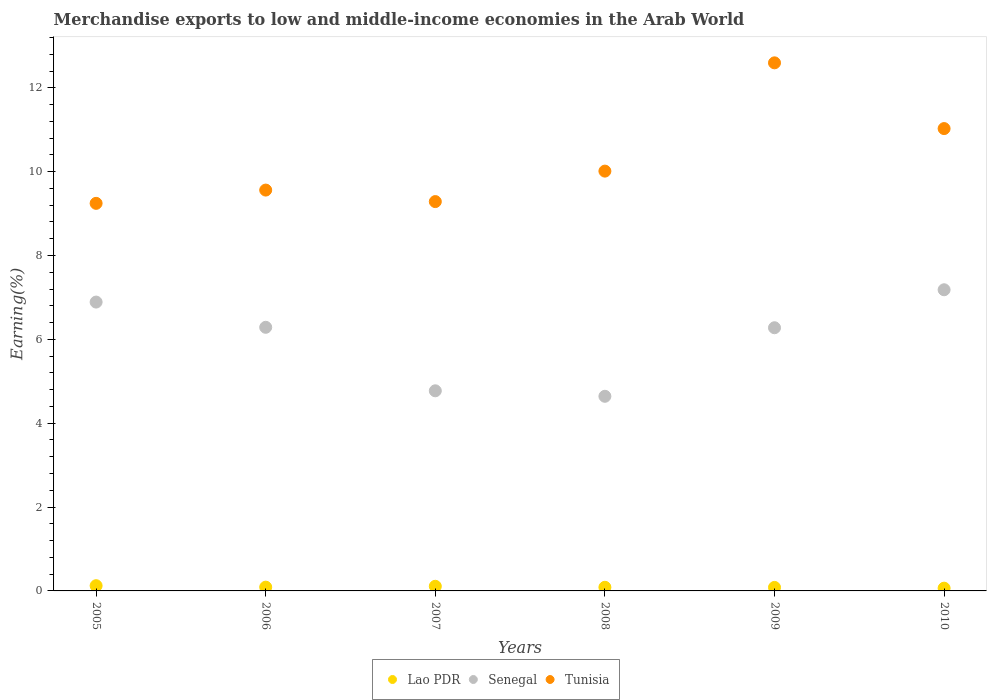Is the number of dotlines equal to the number of legend labels?
Your response must be concise. Yes. What is the percentage of amount earned from merchandise exports in Tunisia in 2005?
Provide a succinct answer. 9.24. Across all years, what is the maximum percentage of amount earned from merchandise exports in Senegal?
Offer a very short reply. 7.18. Across all years, what is the minimum percentage of amount earned from merchandise exports in Tunisia?
Your response must be concise. 9.24. In which year was the percentage of amount earned from merchandise exports in Tunisia maximum?
Ensure brevity in your answer.  2009. What is the total percentage of amount earned from merchandise exports in Tunisia in the graph?
Your answer should be compact. 61.73. What is the difference between the percentage of amount earned from merchandise exports in Senegal in 2005 and that in 2006?
Give a very brief answer. 0.6. What is the difference between the percentage of amount earned from merchandise exports in Tunisia in 2006 and the percentage of amount earned from merchandise exports in Senegal in 2008?
Give a very brief answer. 4.92. What is the average percentage of amount earned from merchandise exports in Senegal per year?
Offer a terse response. 6.01. In the year 2007, what is the difference between the percentage of amount earned from merchandise exports in Lao PDR and percentage of amount earned from merchandise exports in Senegal?
Give a very brief answer. -4.66. In how many years, is the percentage of amount earned from merchandise exports in Lao PDR greater than 8 %?
Make the answer very short. 0. What is the ratio of the percentage of amount earned from merchandise exports in Senegal in 2005 to that in 2008?
Provide a short and direct response. 1.48. Is the difference between the percentage of amount earned from merchandise exports in Lao PDR in 2005 and 2010 greater than the difference between the percentage of amount earned from merchandise exports in Senegal in 2005 and 2010?
Offer a terse response. Yes. What is the difference between the highest and the second highest percentage of amount earned from merchandise exports in Lao PDR?
Your answer should be compact. 0.01. What is the difference between the highest and the lowest percentage of amount earned from merchandise exports in Lao PDR?
Your answer should be compact. 0.06. In how many years, is the percentage of amount earned from merchandise exports in Tunisia greater than the average percentage of amount earned from merchandise exports in Tunisia taken over all years?
Keep it short and to the point. 2. Is the sum of the percentage of amount earned from merchandise exports in Tunisia in 2005 and 2010 greater than the maximum percentage of amount earned from merchandise exports in Senegal across all years?
Offer a very short reply. Yes. Is it the case that in every year, the sum of the percentage of amount earned from merchandise exports in Senegal and percentage of amount earned from merchandise exports in Tunisia  is greater than the percentage of amount earned from merchandise exports in Lao PDR?
Offer a very short reply. Yes. Is the percentage of amount earned from merchandise exports in Lao PDR strictly less than the percentage of amount earned from merchandise exports in Senegal over the years?
Make the answer very short. Yes. How many dotlines are there?
Your answer should be compact. 3. What is the difference between two consecutive major ticks on the Y-axis?
Ensure brevity in your answer.  2. Does the graph contain any zero values?
Make the answer very short. No. Does the graph contain grids?
Your answer should be compact. No. How many legend labels are there?
Keep it short and to the point. 3. What is the title of the graph?
Offer a very short reply. Merchandise exports to low and middle-income economies in the Arab World. What is the label or title of the X-axis?
Give a very brief answer. Years. What is the label or title of the Y-axis?
Keep it short and to the point. Earning(%). What is the Earning(%) in Lao PDR in 2005?
Provide a succinct answer. 0.12. What is the Earning(%) in Senegal in 2005?
Keep it short and to the point. 6.89. What is the Earning(%) of Tunisia in 2005?
Provide a short and direct response. 9.24. What is the Earning(%) of Lao PDR in 2006?
Your answer should be very brief. 0.09. What is the Earning(%) of Senegal in 2006?
Offer a very short reply. 6.29. What is the Earning(%) in Tunisia in 2006?
Your answer should be compact. 9.56. What is the Earning(%) of Lao PDR in 2007?
Your answer should be compact. 0.11. What is the Earning(%) in Senegal in 2007?
Make the answer very short. 4.77. What is the Earning(%) in Tunisia in 2007?
Offer a very short reply. 9.29. What is the Earning(%) in Lao PDR in 2008?
Provide a short and direct response. 0.09. What is the Earning(%) in Senegal in 2008?
Give a very brief answer. 4.64. What is the Earning(%) of Tunisia in 2008?
Provide a short and direct response. 10.01. What is the Earning(%) in Lao PDR in 2009?
Make the answer very short. 0.08. What is the Earning(%) of Senegal in 2009?
Keep it short and to the point. 6.28. What is the Earning(%) in Tunisia in 2009?
Offer a terse response. 12.6. What is the Earning(%) of Lao PDR in 2010?
Make the answer very short. 0.07. What is the Earning(%) of Senegal in 2010?
Offer a very short reply. 7.18. What is the Earning(%) of Tunisia in 2010?
Make the answer very short. 11.03. Across all years, what is the maximum Earning(%) of Lao PDR?
Give a very brief answer. 0.12. Across all years, what is the maximum Earning(%) of Senegal?
Make the answer very short. 7.18. Across all years, what is the maximum Earning(%) of Tunisia?
Keep it short and to the point. 12.6. Across all years, what is the minimum Earning(%) of Lao PDR?
Your answer should be compact. 0.07. Across all years, what is the minimum Earning(%) in Senegal?
Your response must be concise. 4.64. Across all years, what is the minimum Earning(%) of Tunisia?
Provide a succinct answer. 9.24. What is the total Earning(%) of Lao PDR in the graph?
Offer a very short reply. 0.56. What is the total Earning(%) of Senegal in the graph?
Your answer should be compact. 36.05. What is the total Earning(%) in Tunisia in the graph?
Provide a succinct answer. 61.73. What is the difference between the Earning(%) of Lao PDR in 2005 and that in 2006?
Provide a succinct answer. 0.03. What is the difference between the Earning(%) of Senegal in 2005 and that in 2006?
Give a very brief answer. 0.6. What is the difference between the Earning(%) of Tunisia in 2005 and that in 2006?
Keep it short and to the point. -0.32. What is the difference between the Earning(%) of Lao PDR in 2005 and that in 2007?
Give a very brief answer. 0.01. What is the difference between the Earning(%) in Senegal in 2005 and that in 2007?
Your answer should be compact. 2.12. What is the difference between the Earning(%) in Tunisia in 2005 and that in 2007?
Give a very brief answer. -0.04. What is the difference between the Earning(%) in Lao PDR in 2005 and that in 2008?
Give a very brief answer. 0.04. What is the difference between the Earning(%) of Senegal in 2005 and that in 2008?
Your response must be concise. 2.25. What is the difference between the Earning(%) in Tunisia in 2005 and that in 2008?
Your response must be concise. -0.77. What is the difference between the Earning(%) of Lao PDR in 2005 and that in 2009?
Ensure brevity in your answer.  0.04. What is the difference between the Earning(%) of Senegal in 2005 and that in 2009?
Offer a very short reply. 0.61. What is the difference between the Earning(%) of Tunisia in 2005 and that in 2009?
Offer a very short reply. -3.35. What is the difference between the Earning(%) in Lao PDR in 2005 and that in 2010?
Your response must be concise. 0.06. What is the difference between the Earning(%) in Senegal in 2005 and that in 2010?
Provide a succinct answer. -0.29. What is the difference between the Earning(%) of Tunisia in 2005 and that in 2010?
Offer a very short reply. -1.78. What is the difference between the Earning(%) in Lao PDR in 2006 and that in 2007?
Your response must be concise. -0.02. What is the difference between the Earning(%) of Senegal in 2006 and that in 2007?
Make the answer very short. 1.51. What is the difference between the Earning(%) of Tunisia in 2006 and that in 2007?
Provide a succinct answer. 0.27. What is the difference between the Earning(%) of Lao PDR in 2006 and that in 2008?
Provide a short and direct response. 0. What is the difference between the Earning(%) of Senegal in 2006 and that in 2008?
Offer a very short reply. 1.65. What is the difference between the Earning(%) in Tunisia in 2006 and that in 2008?
Your response must be concise. -0.45. What is the difference between the Earning(%) of Lao PDR in 2006 and that in 2009?
Your response must be concise. 0.01. What is the difference between the Earning(%) in Senegal in 2006 and that in 2009?
Ensure brevity in your answer.  0.01. What is the difference between the Earning(%) of Tunisia in 2006 and that in 2009?
Provide a short and direct response. -3.03. What is the difference between the Earning(%) in Lao PDR in 2006 and that in 2010?
Offer a terse response. 0.02. What is the difference between the Earning(%) in Senegal in 2006 and that in 2010?
Offer a very short reply. -0.9. What is the difference between the Earning(%) of Tunisia in 2006 and that in 2010?
Provide a short and direct response. -1.47. What is the difference between the Earning(%) in Lao PDR in 2007 and that in 2008?
Offer a terse response. 0.02. What is the difference between the Earning(%) of Senegal in 2007 and that in 2008?
Keep it short and to the point. 0.13. What is the difference between the Earning(%) of Tunisia in 2007 and that in 2008?
Offer a very short reply. -0.73. What is the difference between the Earning(%) of Lao PDR in 2007 and that in 2009?
Offer a terse response. 0.03. What is the difference between the Earning(%) of Senegal in 2007 and that in 2009?
Make the answer very short. -1.5. What is the difference between the Earning(%) of Tunisia in 2007 and that in 2009?
Offer a terse response. -3.31. What is the difference between the Earning(%) in Lao PDR in 2007 and that in 2010?
Your response must be concise. 0.04. What is the difference between the Earning(%) of Senegal in 2007 and that in 2010?
Your answer should be compact. -2.41. What is the difference between the Earning(%) in Tunisia in 2007 and that in 2010?
Your answer should be compact. -1.74. What is the difference between the Earning(%) of Lao PDR in 2008 and that in 2009?
Your response must be concise. 0. What is the difference between the Earning(%) of Senegal in 2008 and that in 2009?
Provide a succinct answer. -1.64. What is the difference between the Earning(%) in Tunisia in 2008 and that in 2009?
Keep it short and to the point. -2.58. What is the difference between the Earning(%) in Lao PDR in 2008 and that in 2010?
Provide a short and direct response. 0.02. What is the difference between the Earning(%) of Senegal in 2008 and that in 2010?
Ensure brevity in your answer.  -2.54. What is the difference between the Earning(%) of Tunisia in 2008 and that in 2010?
Provide a succinct answer. -1.01. What is the difference between the Earning(%) in Lao PDR in 2009 and that in 2010?
Give a very brief answer. 0.02. What is the difference between the Earning(%) of Senegal in 2009 and that in 2010?
Your answer should be very brief. -0.91. What is the difference between the Earning(%) in Tunisia in 2009 and that in 2010?
Offer a very short reply. 1.57. What is the difference between the Earning(%) in Lao PDR in 2005 and the Earning(%) in Senegal in 2006?
Offer a very short reply. -6.16. What is the difference between the Earning(%) of Lao PDR in 2005 and the Earning(%) of Tunisia in 2006?
Make the answer very short. -9.44. What is the difference between the Earning(%) of Senegal in 2005 and the Earning(%) of Tunisia in 2006?
Offer a very short reply. -2.67. What is the difference between the Earning(%) of Lao PDR in 2005 and the Earning(%) of Senegal in 2007?
Provide a short and direct response. -4.65. What is the difference between the Earning(%) of Lao PDR in 2005 and the Earning(%) of Tunisia in 2007?
Your answer should be compact. -9.16. What is the difference between the Earning(%) of Senegal in 2005 and the Earning(%) of Tunisia in 2007?
Keep it short and to the point. -2.4. What is the difference between the Earning(%) of Lao PDR in 2005 and the Earning(%) of Senegal in 2008?
Give a very brief answer. -4.52. What is the difference between the Earning(%) of Lao PDR in 2005 and the Earning(%) of Tunisia in 2008?
Give a very brief answer. -9.89. What is the difference between the Earning(%) of Senegal in 2005 and the Earning(%) of Tunisia in 2008?
Offer a very short reply. -3.12. What is the difference between the Earning(%) in Lao PDR in 2005 and the Earning(%) in Senegal in 2009?
Make the answer very short. -6.15. What is the difference between the Earning(%) in Lao PDR in 2005 and the Earning(%) in Tunisia in 2009?
Provide a short and direct response. -12.47. What is the difference between the Earning(%) in Senegal in 2005 and the Earning(%) in Tunisia in 2009?
Make the answer very short. -5.71. What is the difference between the Earning(%) in Lao PDR in 2005 and the Earning(%) in Senegal in 2010?
Keep it short and to the point. -7.06. What is the difference between the Earning(%) in Lao PDR in 2005 and the Earning(%) in Tunisia in 2010?
Your response must be concise. -10.9. What is the difference between the Earning(%) in Senegal in 2005 and the Earning(%) in Tunisia in 2010?
Provide a succinct answer. -4.14. What is the difference between the Earning(%) in Lao PDR in 2006 and the Earning(%) in Senegal in 2007?
Make the answer very short. -4.68. What is the difference between the Earning(%) of Lao PDR in 2006 and the Earning(%) of Tunisia in 2007?
Provide a succinct answer. -9.2. What is the difference between the Earning(%) in Senegal in 2006 and the Earning(%) in Tunisia in 2007?
Offer a very short reply. -3. What is the difference between the Earning(%) of Lao PDR in 2006 and the Earning(%) of Senegal in 2008?
Give a very brief answer. -4.55. What is the difference between the Earning(%) in Lao PDR in 2006 and the Earning(%) in Tunisia in 2008?
Your answer should be compact. -9.92. What is the difference between the Earning(%) of Senegal in 2006 and the Earning(%) of Tunisia in 2008?
Make the answer very short. -3.73. What is the difference between the Earning(%) in Lao PDR in 2006 and the Earning(%) in Senegal in 2009?
Provide a succinct answer. -6.19. What is the difference between the Earning(%) in Lao PDR in 2006 and the Earning(%) in Tunisia in 2009?
Keep it short and to the point. -12.51. What is the difference between the Earning(%) in Senegal in 2006 and the Earning(%) in Tunisia in 2009?
Your answer should be very brief. -6.31. What is the difference between the Earning(%) in Lao PDR in 2006 and the Earning(%) in Senegal in 2010?
Offer a very short reply. -7.09. What is the difference between the Earning(%) of Lao PDR in 2006 and the Earning(%) of Tunisia in 2010?
Your answer should be very brief. -10.94. What is the difference between the Earning(%) of Senegal in 2006 and the Earning(%) of Tunisia in 2010?
Keep it short and to the point. -4.74. What is the difference between the Earning(%) in Lao PDR in 2007 and the Earning(%) in Senegal in 2008?
Provide a succinct answer. -4.53. What is the difference between the Earning(%) in Lao PDR in 2007 and the Earning(%) in Tunisia in 2008?
Your response must be concise. -9.9. What is the difference between the Earning(%) in Senegal in 2007 and the Earning(%) in Tunisia in 2008?
Your answer should be very brief. -5.24. What is the difference between the Earning(%) in Lao PDR in 2007 and the Earning(%) in Senegal in 2009?
Your answer should be compact. -6.17. What is the difference between the Earning(%) in Lao PDR in 2007 and the Earning(%) in Tunisia in 2009?
Offer a terse response. -12.48. What is the difference between the Earning(%) in Senegal in 2007 and the Earning(%) in Tunisia in 2009?
Provide a short and direct response. -7.82. What is the difference between the Earning(%) in Lao PDR in 2007 and the Earning(%) in Senegal in 2010?
Offer a terse response. -7.07. What is the difference between the Earning(%) in Lao PDR in 2007 and the Earning(%) in Tunisia in 2010?
Offer a terse response. -10.92. What is the difference between the Earning(%) in Senegal in 2007 and the Earning(%) in Tunisia in 2010?
Give a very brief answer. -6.25. What is the difference between the Earning(%) of Lao PDR in 2008 and the Earning(%) of Senegal in 2009?
Ensure brevity in your answer.  -6.19. What is the difference between the Earning(%) in Lao PDR in 2008 and the Earning(%) in Tunisia in 2009?
Keep it short and to the point. -12.51. What is the difference between the Earning(%) of Senegal in 2008 and the Earning(%) of Tunisia in 2009?
Your response must be concise. -7.95. What is the difference between the Earning(%) of Lao PDR in 2008 and the Earning(%) of Senegal in 2010?
Keep it short and to the point. -7.1. What is the difference between the Earning(%) of Lao PDR in 2008 and the Earning(%) of Tunisia in 2010?
Offer a terse response. -10.94. What is the difference between the Earning(%) of Senegal in 2008 and the Earning(%) of Tunisia in 2010?
Keep it short and to the point. -6.39. What is the difference between the Earning(%) of Lao PDR in 2009 and the Earning(%) of Senegal in 2010?
Provide a succinct answer. -7.1. What is the difference between the Earning(%) in Lao PDR in 2009 and the Earning(%) in Tunisia in 2010?
Provide a succinct answer. -10.94. What is the difference between the Earning(%) of Senegal in 2009 and the Earning(%) of Tunisia in 2010?
Make the answer very short. -4.75. What is the average Earning(%) of Lao PDR per year?
Your answer should be very brief. 0.09. What is the average Earning(%) in Senegal per year?
Your answer should be compact. 6.01. What is the average Earning(%) in Tunisia per year?
Your answer should be very brief. 10.29. In the year 2005, what is the difference between the Earning(%) of Lao PDR and Earning(%) of Senegal?
Provide a succinct answer. -6.76. In the year 2005, what is the difference between the Earning(%) of Lao PDR and Earning(%) of Tunisia?
Your answer should be compact. -9.12. In the year 2005, what is the difference between the Earning(%) in Senegal and Earning(%) in Tunisia?
Ensure brevity in your answer.  -2.35. In the year 2006, what is the difference between the Earning(%) of Lao PDR and Earning(%) of Senegal?
Offer a very short reply. -6.2. In the year 2006, what is the difference between the Earning(%) in Lao PDR and Earning(%) in Tunisia?
Provide a short and direct response. -9.47. In the year 2006, what is the difference between the Earning(%) in Senegal and Earning(%) in Tunisia?
Offer a terse response. -3.27. In the year 2007, what is the difference between the Earning(%) of Lao PDR and Earning(%) of Senegal?
Keep it short and to the point. -4.66. In the year 2007, what is the difference between the Earning(%) in Lao PDR and Earning(%) in Tunisia?
Ensure brevity in your answer.  -9.18. In the year 2007, what is the difference between the Earning(%) in Senegal and Earning(%) in Tunisia?
Offer a very short reply. -4.51. In the year 2008, what is the difference between the Earning(%) of Lao PDR and Earning(%) of Senegal?
Your answer should be compact. -4.56. In the year 2008, what is the difference between the Earning(%) of Lao PDR and Earning(%) of Tunisia?
Provide a succinct answer. -9.93. In the year 2008, what is the difference between the Earning(%) of Senegal and Earning(%) of Tunisia?
Make the answer very short. -5.37. In the year 2009, what is the difference between the Earning(%) in Lao PDR and Earning(%) in Senegal?
Make the answer very short. -6.19. In the year 2009, what is the difference between the Earning(%) in Lao PDR and Earning(%) in Tunisia?
Ensure brevity in your answer.  -12.51. In the year 2009, what is the difference between the Earning(%) in Senegal and Earning(%) in Tunisia?
Give a very brief answer. -6.32. In the year 2010, what is the difference between the Earning(%) of Lao PDR and Earning(%) of Senegal?
Make the answer very short. -7.12. In the year 2010, what is the difference between the Earning(%) of Lao PDR and Earning(%) of Tunisia?
Provide a succinct answer. -10.96. In the year 2010, what is the difference between the Earning(%) in Senegal and Earning(%) in Tunisia?
Offer a very short reply. -3.84. What is the ratio of the Earning(%) of Lao PDR in 2005 to that in 2006?
Keep it short and to the point. 1.38. What is the ratio of the Earning(%) in Senegal in 2005 to that in 2006?
Offer a very short reply. 1.1. What is the ratio of the Earning(%) of Tunisia in 2005 to that in 2006?
Your answer should be compact. 0.97. What is the ratio of the Earning(%) in Lao PDR in 2005 to that in 2007?
Provide a short and direct response. 1.13. What is the ratio of the Earning(%) in Senegal in 2005 to that in 2007?
Your answer should be compact. 1.44. What is the ratio of the Earning(%) in Lao PDR in 2005 to that in 2008?
Provide a short and direct response. 1.44. What is the ratio of the Earning(%) in Senegal in 2005 to that in 2008?
Provide a succinct answer. 1.48. What is the ratio of the Earning(%) of Tunisia in 2005 to that in 2008?
Provide a succinct answer. 0.92. What is the ratio of the Earning(%) in Lao PDR in 2005 to that in 2009?
Your response must be concise. 1.49. What is the ratio of the Earning(%) in Senegal in 2005 to that in 2009?
Your answer should be very brief. 1.1. What is the ratio of the Earning(%) in Tunisia in 2005 to that in 2009?
Give a very brief answer. 0.73. What is the ratio of the Earning(%) in Lao PDR in 2005 to that in 2010?
Give a very brief answer. 1.89. What is the ratio of the Earning(%) of Senegal in 2005 to that in 2010?
Ensure brevity in your answer.  0.96. What is the ratio of the Earning(%) of Tunisia in 2005 to that in 2010?
Make the answer very short. 0.84. What is the ratio of the Earning(%) in Lao PDR in 2006 to that in 2007?
Provide a succinct answer. 0.81. What is the ratio of the Earning(%) in Senegal in 2006 to that in 2007?
Make the answer very short. 1.32. What is the ratio of the Earning(%) in Tunisia in 2006 to that in 2007?
Offer a terse response. 1.03. What is the ratio of the Earning(%) in Lao PDR in 2006 to that in 2008?
Offer a very short reply. 1.04. What is the ratio of the Earning(%) in Senegal in 2006 to that in 2008?
Keep it short and to the point. 1.35. What is the ratio of the Earning(%) of Tunisia in 2006 to that in 2008?
Your answer should be very brief. 0.95. What is the ratio of the Earning(%) in Lao PDR in 2006 to that in 2009?
Offer a very short reply. 1.08. What is the ratio of the Earning(%) in Senegal in 2006 to that in 2009?
Make the answer very short. 1. What is the ratio of the Earning(%) of Tunisia in 2006 to that in 2009?
Give a very brief answer. 0.76. What is the ratio of the Earning(%) of Lao PDR in 2006 to that in 2010?
Offer a very short reply. 1.37. What is the ratio of the Earning(%) in Senegal in 2006 to that in 2010?
Give a very brief answer. 0.88. What is the ratio of the Earning(%) of Tunisia in 2006 to that in 2010?
Ensure brevity in your answer.  0.87. What is the ratio of the Earning(%) of Lao PDR in 2007 to that in 2008?
Provide a short and direct response. 1.28. What is the ratio of the Earning(%) in Senegal in 2007 to that in 2008?
Offer a terse response. 1.03. What is the ratio of the Earning(%) of Tunisia in 2007 to that in 2008?
Keep it short and to the point. 0.93. What is the ratio of the Earning(%) in Lao PDR in 2007 to that in 2009?
Your answer should be compact. 1.32. What is the ratio of the Earning(%) of Senegal in 2007 to that in 2009?
Provide a succinct answer. 0.76. What is the ratio of the Earning(%) in Tunisia in 2007 to that in 2009?
Offer a very short reply. 0.74. What is the ratio of the Earning(%) in Lao PDR in 2007 to that in 2010?
Offer a very short reply. 1.68. What is the ratio of the Earning(%) in Senegal in 2007 to that in 2010?
Your answer should be very brief. 0.66. What is the ratio of the Earning(%) of Tunisia in 2007 to that in 2010?
Ensure brevity in your answer.  0.84. What is the ratio of the Earning(%) in Lao PDR in 2008 to that in 2009?
Offer a terse response. 1.04. What is the ratio of the Earning(%) of Senegal in 2008 to that in 2009?
Provide a succinct answer. 0.74. What is the ratio of the Earning(%) in Tunisia in 2008 to that in 2009?
Offer a terse response. 0.8. What is the ratio of the Earning(%) of Lao PDR in 2008 to that in 2010?
Make the answer very short. 1.32. What is the ratio of the Earning(%) in Senegal in 2008 to that in 2010?
Give a very brief answer. 0.65. What is the ratio of the Earning(%) of Tunisia in 2008 to that in 2010?
Your response must be concise. 0.91. What is the ratio of the Earning(%) in Lao PDR in 2009 to that in 2010?
Keep it short and to the point. 1.27. What is the ratio of the Earning(%) in Senegal in 2009 to that in 2010?
Provide a succinct answer. 0.87. What is the ratio of the Earning(%) of Tunisia in 2009 to that in 2010?
Provide a succinct answer. 1.14. What is the difference between the highest and the second highest Earning(%) of Lao PDR?
Your answer should be very brief. 0.01. What is the difference between the highest and the second highest Earning(%) in Senegal?
Offer a very short reply. 0.29. What is the difference between the highest and the second highest Earning(%) in Tunisia?
Ensure brevity in your answer.  1.57. What is the difference between the highest and the lowest Earning(%) in Lao PDR?
Keep it short and to the point. 0.06. What is the difference between the highest and the lowest Earning(%) in Senegal?
Your answer should be very brief. 2.54. What is the difference between the highest and the lowest Earning(%) in Tunisia?
Make the answer very short. 3.35. 